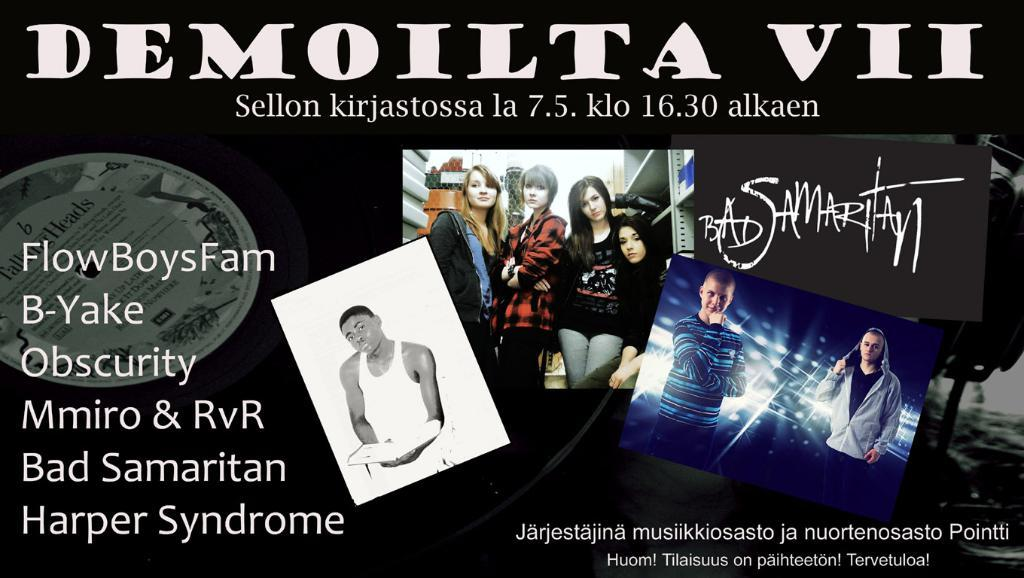<image>
Render a clear and concise summary of the photo. A poster or ad for Demoilta VII with pictures of different bands. 